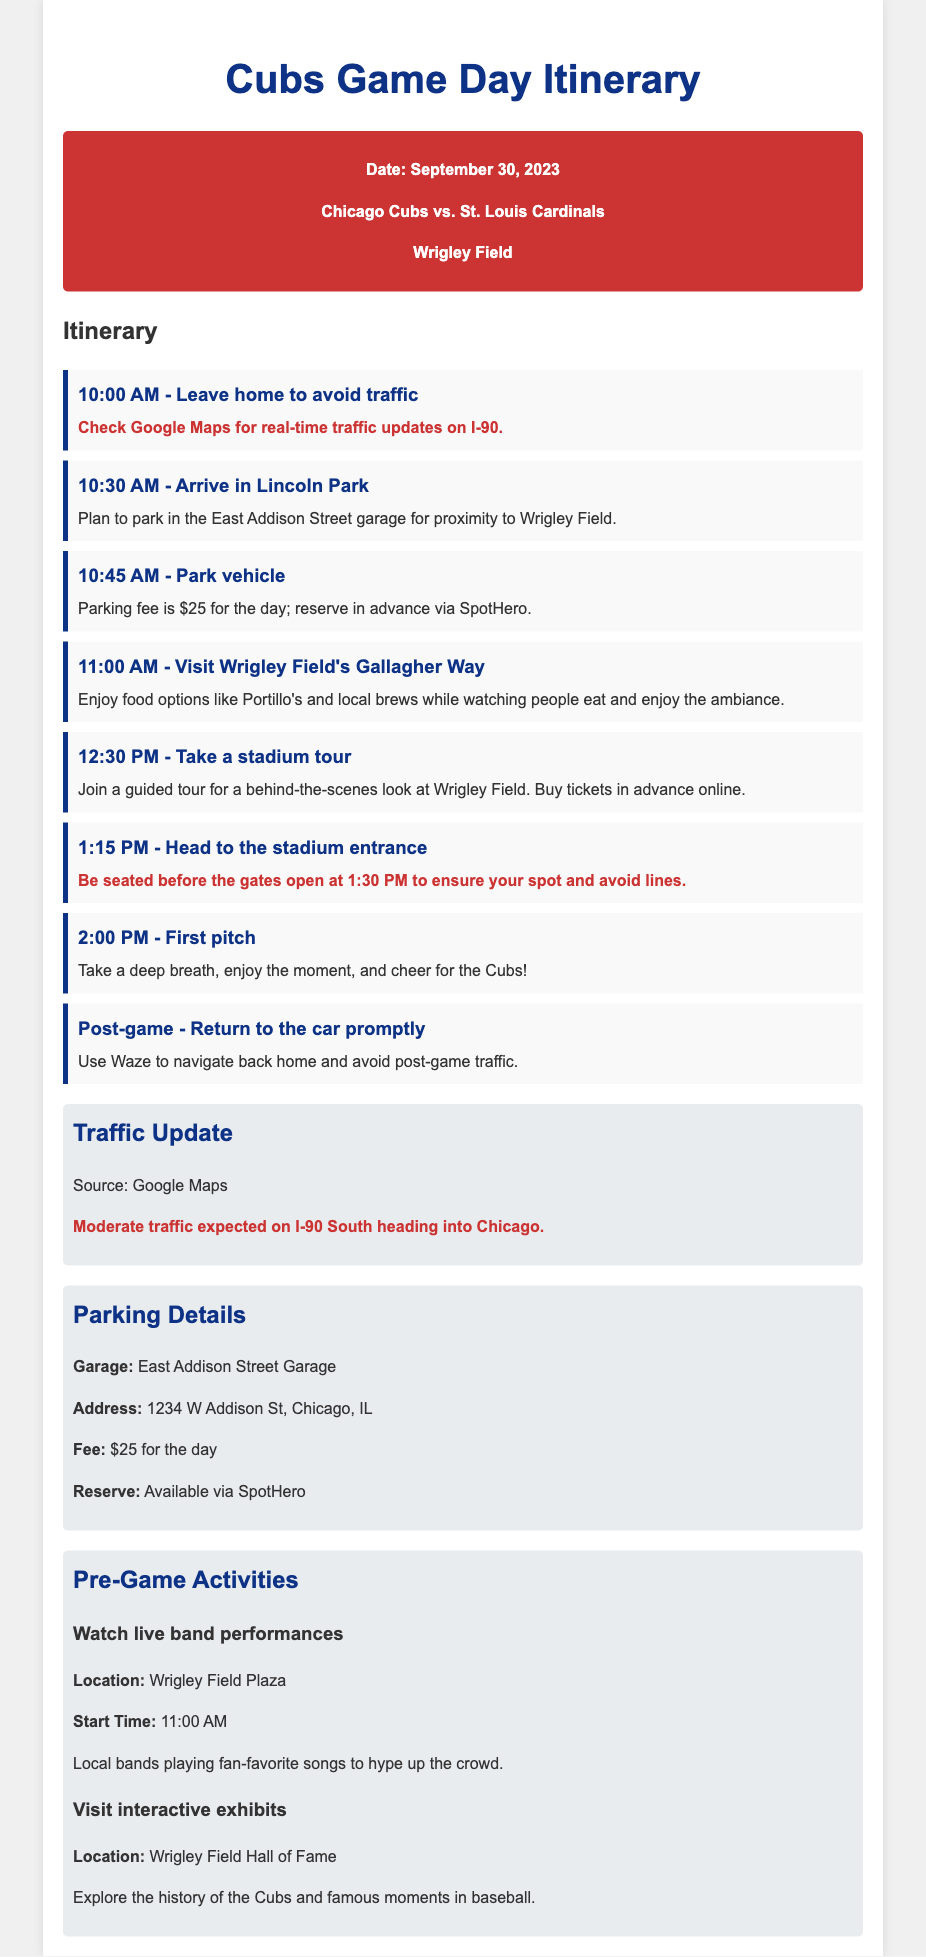what is the date of the game? The date of the game is specified in the document as September 30, 2023.
Answer: September 30, 2023 who are the opponents? The opponents playing in the game are the Chicago Cubs and the St. Louis Cardinals.
Answer: Chicago Cubs vs. St. Louis Cardinals what time should you leave home to avoid traffic? The itinerary specifies leaving home at 10:00 AM to avoid traffic.
Answer: 10:00 AM where should you park your vehicle? The document suggests parking in the East Addison Street garage for its proximity to Wrigley Field.
Answer: East Addison Street garage how much is the parking fee? The parking fee for the day is mentioned as $25.
Answer: $25 what is the warning regarding the stadium entrance? The warning states to be seated before the gates open at 1:30 PM to avoid lines.
Answer: Be seated before 1:30 PM what is one of the pre-game activities listed? The document lists visiting interactive exhibits as one of the pre-game activities.
Answer: Visit interactive exhibits when is the first pitch scheduled? The time for the first pitch is stated as 2:00 PM in the itinerary.
Answer: 2:00 PM what is expected on I-90 South? The document warns of moderate traffic expected on I-90 South heading into Chicago.
Answer: Moderate traffic 